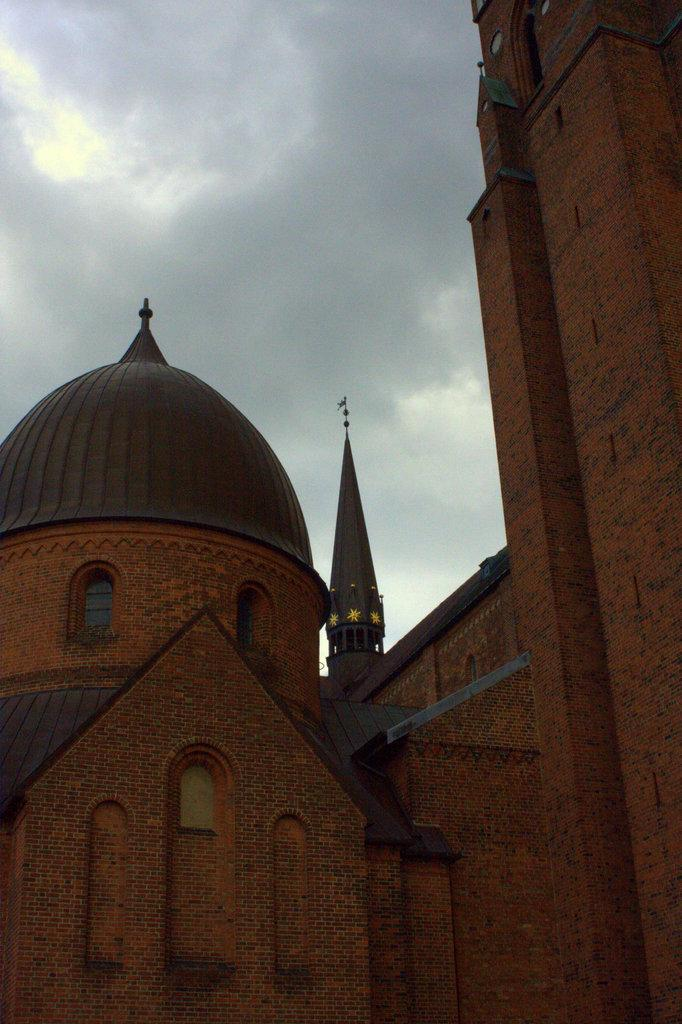What type of structures can be seen in the image? There are buildings in the image. What feature can be observed on the buildings? Windows are visible in the image. What is visible in the sky in the image? Clouds are present in the sky in the image. What type of brass instrument is being played in the image? There is no brass instrument or any indication of musical activity in the image. 